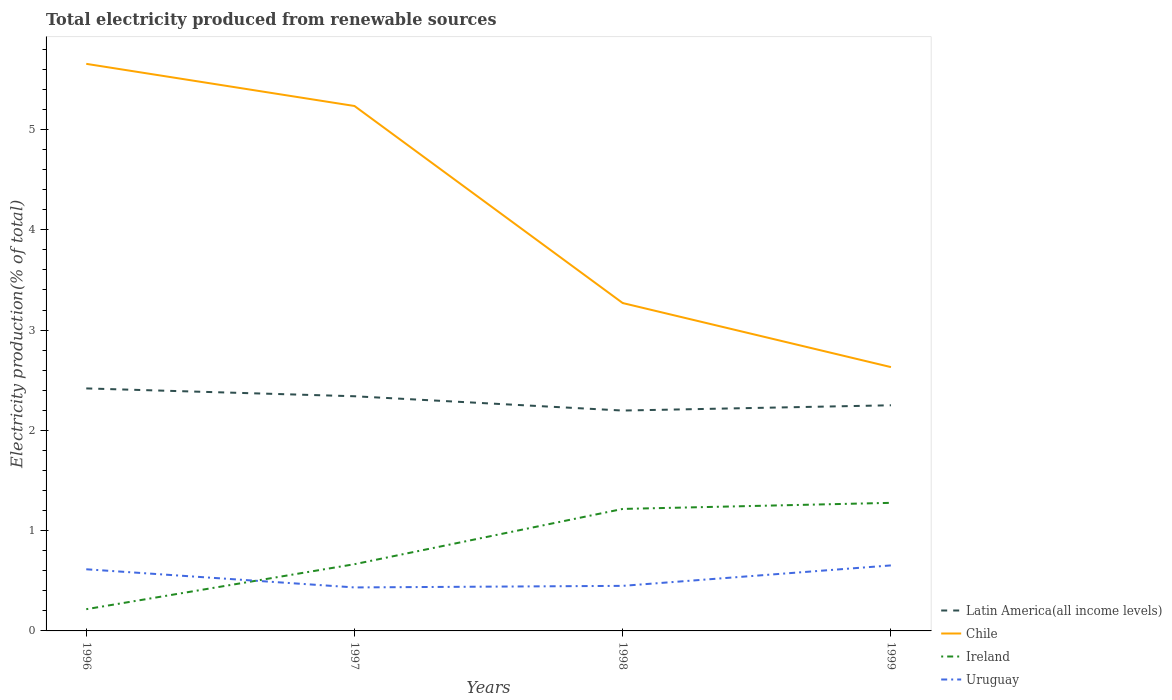Does the line corresponding to Uruguay intersect with the line corresponding to Chile?
Your response must be concise. No. Is the number of lines equal to the number of legend labels?
Your answer should be very brief. Yes. Across all years, what is the maximum total electricity produced in Uruguay?
Offer a terse response. 0.43. What is the total total electricity produced in Ireland in the graph?
Keep it short and to the point. -1.06. What is the difference between the highest and the second highest total electricity produced in Chile?
Your answer should be very brief. 3.02. What is the difference between the highest and the lowest total electricity produced in Ireland?
Give a very brief answer. 2. How many lines are there?
Offer a terse response. 4. What is the difference between two consecutive major ticks on the Y-axis?
Provide a short and direct response. 1. Where does the legend appear in the graph?
Provide a succinct answer. Bottom right. How are the legend labels stacked?
Offer a terse response. Vertical. What is the title of the graph?
Your response must be concise. Total electricity produced from renewable sources. What is the Electricity production(% of total) of Latin America(all income levels) in 1996?
Your answer should be compact. 2.42. What is the Electricity production(% of total) in Chile in 1996?
Your answer should be very brief. 5.66. What is the Electricity production(% of total) in Ireland in 1996?
Keep it short and to the point. 0.22. What is the Electricity production(% of total) of Uruguay in 1996?
Offer a terse response. 0.61. What is the Electricity production(% of total) in Latin America(all income levels) in 1997?
Give a very brief answer. 2.34. What is the Electricity production(% of total) in Chile in 1997?
Offer a terse response. 5.23. What is the Electricity production(% of total) in Ireland in 1997?
Offer a terse response. 0.67. What is the Electricity production(% of total) of Uruguay in 1997?
Provide a short and direct response. 0.43. What is the Electricity production(% of total) in Latin America(all income levels) in 1998?
Ensure brevity in your answer.  2.2. What is the Electricity production(% of total) in Chile in 1998?
Make the answer very short. 3.27. What is the Electricity production(% of total) of Ireland in 1998?
Give a very brief answer. 1.22. What is the Electricity production(% of total) in Uruguay in 1998?
Offer a very short reply. 0.45. What is the Electricity production(% of total) in Latin America(all income levels) in 1999?
Offer a very short reply. 2.25. What is the Electricity production(% of total) of Chile in 1999?
Offer a very short reply. 2.63. What is the Electricity production(% of total) of Ireland in 1999?
Give a very brief answer. 1.28. What is the Electricity production(% of total) in Uruguay in 1999?
Offer a terse response. 0.65. Across all years, what is the maximum Electricity production(% of total) of Latin America(all income levels)?
Offer a terse response. 2.42. Across all years, what is the maximum Electricity production(% of total) of Chile?
Keep it short and to the point. 5.66. Across all years, what is the maximum Electricity production(% of total) in Ireland?
Keep it short and to the point. 1.28. Across all years, what is the maximum Electricity production(% of total) of Uruguay?
Offer a terse response. 0.65. Across all years, what is the minimum Electricity production(% of total) of Latin America(all income levels)?
Offer a very short reply. 2.2. Across all years, what is the minimum Electricity production(% of total) of Chile?
Your answer should be very brief. 2.63. Across all years, what is the minimum Electricity production(% of total) of Ireland?
Your answer should be compact. 0.22. Across all years, what is the minimum Electricity production(% of total) in Uruguay?
Your answer should be compact. 0.43. What is the total Electricity production(% of total) of Latin America(all income levels) in the graph?
Provide a short and direct response. 9.21. What is the total Electricity production(% of total) in Chile in the graph?
Offer a very short reply. 16.79. What is the total Electricity production(% of total) of Ireland in the graph?
Make the answer very short. 3.38. What is the total Electricity production(% of total) of Uruguay in the graph?
Offer a terse response. 2.15. What is the difference between the Electricity production(% of total) of Latin America(all income levels) in 1996 and that in 1997?
Make the answer very short. 0.08. What is the difference between the Electricity production(% of total) in Chile in 1996 and that in 1997?
Your answer should be compact. 0.42. What is the difference between the Electricity production(% of total) in Ireland in 1996 and that in 1997?
Give a very brief answer. -0.45. What is the difference between the Electricity production(% of total) of Uruguay in 1996 and that in 1997?
Offer a terse response. 0.18. What is the difference between the Electricity production(% of total) of Latin America(all income levels) in 1996 and that in 1998?
Make the answer very short. 0.22. What is the difference between the Electricity production(% of total) of Chile in 1996 and that in 1998?
Provide a short and direct response. 2.39. What is the difference between the Electricity production(% of total) in Ireland in 1996 and that in 1998?
Your answer should be compact. -1. What is the difference between the Electricity production(% of total) in Uruguay in 1996 and that in 1998?
Your answer should be compact. 0.17. What is the difference between the Electricity production(% of total) in Latin America(all income levels) in 1996 and that in 1999?
Your answer should be very brief. 0.17. What is the difference between the Electricity production(% of total) of Chile in 1996 and that in 1999?
Keep it short and to the point. 3.02. What is the difference between the Electricity production(% of total) of Ireland in 1996 and that in 1999?
Give a very brief answer. -1.06. What is the difference between the Electricity production(% of total) in Uruguay in 1996 and that in 1999?
Your answer should be compact. -0.04. What is the difference between the Electricity production(% of total) in Latin America(all income levels) in 1997 and that in 1998?
Give a very brief answer. 0.14. What is the difference between the Electricity production(% of total) in Chile in 1997 and that in 1998?
Your response must be concise. 1.97. What is the difference between the Electricity production(% of total) in Ireland in 1997 and that in 1998?
Give a very brief answer. -0.55. What is the difference between the Electricity production(% of total) of Uruguay in 1997 and that in 1998?
Your answer should be compact. -0.02. What is the difference between the Electricity production(% of total) in Latin America(all income levels) in 1997 and that in 1999?
Give a very brief answer. 0.09. What is the difference between the Electricity production(% of total) of Chile in 1997 and that in 1999?
Give a very brief answer. 2.6. What is the difference between the Electricity production(% of total) in Ireland in 1997 and that in 1999?
Provide a short and direct response. -0.61. What is the difference between the Electricity production(% of total) in Uruguay in 1997 and that in 1999?
Ensure brevity in your answer.  -0.22. What is the difference between the Electricity production(% of total) of Latin America(all income levels) in 1998 and that in 1999?
Make the answer very short. -0.05. What is the difference between the Electricity production(% of total) of Chile in 1998 and that in 1999?
Give a very brief answer. 0.64. What is the difference between the Electricity production(% of total) of Ireland in 1998 and that in 1999?
Provide a succinct answer. -0.06. What is the difference between the Electricity production(% of total) in Uruguay in 1998 and that in 1999?
Give a very brief answer. -0.2. What is the difference between the Electricity production(% of total) of Latin America(all income levels) in 1996 and the Electricity production(% of total) of Chile in 1997?
Offer a very short reply. -2.82. What is the difference between the Electricity production(% of total) of Latin America(all income levels) in 1996 and the Electricity production(% of total) of Ireland in 1997?
Provide a succinct answer. 1.75. What is the difference between the Electricity production(% of total) in Latin America(all income levels) in 1996 and the Electricity production(% of total) in Uruguay in 1997?
Offer a very short reply. 1.98. What is the difference between the Electricity production(% of total) of Chile in 1996 and the Electricity production(% of total) of Ireland in 1997?
Provide a short and direct response. 4.99. What is the difference between the Electricity production(% of total) of Chile in 1996 and the Electricity production(% of total) of Uruguay in 1997?
Offer a very short reply. 5.22. What is the difference between the Electricity production(% of total) of Ireland in 1996 and the Electricity production(% of total) of Uruguay in 1997?
Keep it short and to the point. -0.22. What is the difference between the Electricity production(% of total) of Latin America(all income levels) in 1996 and the Electricity production(% of total) of Chile in 1998?
Provide a succinct answer. -0.85. What is the difference between the Electricity production(% of total) in Latin America(all income levels) in 1996 and the Electricity production(% of total) in Ireland in 1998?
Provide a succinct answer. 1.2. What is the difference between the Electricity production(% of total) in Latin America(all income levels) in 1996 and the Electricity production(% of total) in Uruguay in 1998?
Your answer should be compact. 1.97. What is the difference between the Electricity production(% of total) in Chile in 1996 and the Electricity production(% of total) in Ireland in 1998?
Your response must be concise. 4.44. What is the difference between the Electricity production(% of total) in Chile in 1996 and the Electricity production(% of total) in Uruguay in 1998?
Keep it short and to the point. 5.21. What is the difference between the Electricity production(% of total) in Ireland in 1996 and the Electricity production(% of total) in Uruguay in 1998?
Your response must be concise. -0.23. What is the difference between the Electricity production(% of total) in Latin America(all income levels) in 1996 and the Electricity production(% of total) in Chile in 1999?
Provide a short and direct response. -0.21. What is the difference between the Electricity production(% of total) of Latin America(all income levels) in 1996 and the Electricity production(% of total) of Ireland in 1999?
Your answer should be very brief. 1.14. What is the difference between the Electricity production(% of total) of Latin America(all income levels) in 1996 and the Electricity production(% of total) of Uruguay in 1999?
Your answer should be very brief. 1.76. What is the difference between the Electricity production(% of total) in Chile in 1996 and the Electricity production(% of total) in Ireland in 1999?
Offer a terse response. 4.38. What is the difference between the Electricity production(% of total) in Chile in 1996 and the Electricity production(% of total) in Uruguay in 1999?
Make the answer very short. 5. What is the difference between the Electricity production(% of total) in Ireland in 1996 and the Electricity production(% of total) in Uruguay in 1999?
Keep it short and to the point. -0.44. What is the difference between the Electricity production(% of total) in Latin America(all income levels) in 1997 and the Electricity production(% of total) in Chile in 1998?
Offer a terse response. -0.93. What is the difference between the Electricity production(% of total) of Latin America(all income levels) in 1997 and the Electricity production(% of total) of Ireland in 1998?
Your answer should be compact. 1.12. What is the difference between the Electricity production(% of total) in Latin America(all income levels) in 1997 and the Electricity production(% of total) in Uruguay in 1998?
Keep it short and to the point. 1.89. What is the difference between the Electricity production(% of total) in Chile in 1997 and the Electricity production(% of total) in Ireland in 1998?
Make the answer very short. 4.02. What is the difference between the Electricity production(% of total) of Chile in 1997 and the Electricity production(% of total) of Uruguay in 1998?
Keep it short and to the point. 4.79. What is the difference between the Electricity production(% of total) in Ireland in 1997 and the Electricity production(% of total) in Uruguay in 1998?
Provide a short and direct response. 0.22. What is the difference between the Electricity production(% of total) in Latin America(all income levels) in 1997 and the Electricity production(% of total) in Chile in 1999?
Ensure brevity in your answer.  -0.29. What is the difference between the Electricity production(% of total) in Latin America(all income levels) in 1997 and the Electricity production(% of total) in Ireland in 1999?
Keep it short and to the point. 1.06. What is the difference between the Electricity production(% of total) in Latin America(all income levels) in 1997 and the Electricity production(% of total) in Uruguay in 1999?
Provide a short and direct response. 1.69. What is the difference between the Electricity production(% of total) of Chile in 1997 and the Electricity production(% of total) of Ireland in 1999?
Ensure brevity in your answer.  3.96. What is the difference between the Electricity production(% of total) in Chile in 1997 and the Electricity production(% of total) in Uruguay in 1999?
Ensure brevity in your answer.  4.58. What is the difference between the Electricity production(% of total) in Ireland in 1997 and the Electricity production(% of total) in Uruguay in 1999?
Give a very brief answer. 0.01. What is the difference between the Electricity production(% of total) in Latin America(all income levels) in 1998 and the Electricity production(% of total) in Chile in 1999?
Keep it short and to the point. -0.43. What is the difference between the Electricity production(% of total) in Latin America(all income levels) in 1998 and the Electricity production(% of total) in Ireland in 1999?
Your answer should be very brief. 0.92. What is the difference between the Electricity production(% of total) of Latin America(all income levels) in 1998 and the Electricity production(% of total) of Uruguay in 1999?
Give a very brief answer. 1.54. What is the difference between the Electricity production(% of total) of Chile in 1998 and the Electricity production(% of total) of Ireland in 1999?
Your answer should be compact. 1.99. What is the difference between the Electricity production(% of total) of Chile in 1998 and the Electricity production(% of total) of Uruguay in 1999?
Provide a succinct answer. 2.62. What is the difference between the Electricity production(% of total) in Ireland in 1998 and the Electricity production(% of total) in Uruguay in 1999?
Offer a very short reply. 0.56. What is the average Electricity production(% of total) of Latin America(all income levels) per year?
Make the answer very short. 2.3. What is the average Electricity production(% of total) of Chile per year?
Keep it short and to the point. 4.2. What is the average Electricity production(% of total) of Ireland per year?
Your answer should be very brief. 0.84. What is the average Electricity production(% of total) of Uruguay per year?
Make the answer very short. 0.54. In the year 1996, what is the difference between the Electricity production(% of total) of Latin America(all income levels) and Electricity production(% of total) of Chile?
Offer a terse response. -3.24. In the year 1996, what is the difference between the Electricity production(% of total) in Latin America(all income levels) and Electricity production(% of total) in Ireland?
Give a very brief answer. 2.2. In the year 1996, what is the difference between the Electricity production(% of total) of Latin America(all income levels) and Electricity production(% of total) of Uruguay?
Your answer should be very brief. 1.8. In the year 1996, what is the difference between the Electricity production(% of total) of Chile and Electricity production(% of total) of Ireland?
Keep it short and to the point. 5.44. In the year 1996, what is the difference between the Electricity production(% of total) in Chile and Electricity production(% of total) in Uruguay?
Give a very brief answer. 5.04. In the year 1996, what is the difference between the Electricity production(% of total) of Ireland and Electricity production(% of total) of Uruguay?
Your answer should be very brief. -0.4. In the year 1997, what is the difference between the Electricity production(% of total) in Latin America(all income levels) and Electricity production(% of total) in Chile?
Your answer should be compact. -2.89. In the year 1997, what is the difference between the Electricity production(% of total) in Latin America(all income levels) and Electricity production(% of total) in Ireland?
Your answer should be compact. 1.67. In the year 1997, what is the difference between the Electricity production(% of total) of Latin America(all income levels) and Electricity production(% of total) of Uruguay?
Keep it short and to the point. 1.91. In the year 1997, what is the difference between the Electricity production(% of total) of Chile and Electricity production(% of total) of Ireland?
Ensure brevity in your answer.  4.57. In the year 1997, what is the difference between the Electricity production(% of total) of Chile and Electricity production(% of total) of Uruguay?
Your answer should be compact. 4.8. In the year 1997, what is the difference between the Electricity production(% of total) of Ireland and Electricity production(% of total) of Uruguay?
Provide a succinct answer. 0.23. In the year 1998, what is the difference between the Electricity production(% of total) of Latin America(all income levels) and Electricity production(% of total) of Chile?
Your response must be concise. -1.07. In the year 1998, what is the difference between the Electricity production(% of total) of Latin America(all income levels) and Electricity production(% of total) of Ireland?
Provide a short and direct response. 0.98. In the year 1998, what is the difference between the Electricity production(% of total) of Latin America(all income levels) and Electricity production(% of total) of Uruguay?
Your answer should be compact. 1.75. In the year 1998, what is the difference between the Electricity production(% of total) in Chile and Electricity production(% of total) in Ireland?
Offer a very short reply. 2.05. In the year 1998, what is the difference between the Electricity production(% of total) of Chile and Electricity production(% of total) of Uruguay?
Ensure brevity in your answer.  2.82. In the year 1998, what is the difference between the Electricity production(% of total) in Ireland and Electricity production(% of total) in Uruguay?
Offer a very short reply. 0.77. In the year 1999, what is the difference between the Electricity production(% of total) in Latin America(all income levels) and Electricity production(% of total) in Chile?
Provide a short and direct response. -0.38. In the year 1999, what is the difference between the Electricity production(% of total) in Latin America(all income levels) and Electricity production(% of total) in Ireland?
Your response must be concise. 0.97. In the year 1999, what is the difference between the Electricity production(% of total) in Latin America(all income levels) and Electricity production(% of total) in Uruguay?
Ensure brevity in your answer.  1.6. In the year 1999, what is the difference between the Electricity production(% of total) of Chile and Electricity production(% of total) of Ireland?
Your answer should be compact. 1.35. In the year 1999, what is the difference between the Electricity production(% of total) in Chile and Electricity production(% of total) in Uruguay?
Give a very brief answer. 1.98. In the year 1999, what is the difference between the Electricity production(% of total) in Ireland and Electricity production(% of total) in Uruguay?
Your response must be concise. 0.62. What is the ratio of the Electricity production(% of total) in Latin America(all income levels) in 1996 to that in 1997?
Ensure brevity in your answer.  1.03. What is the ratio of the Electricity production(% of total) of Chile in 1996 to that in 1997?
Make the answer very short. 1.08. What is the ratio of the Electricity production(% of total) of Ireland in 1996 to that in 1997?
Offer a terse response. 0.33. What is the ratio of the Electricity production(% of total) in Uruguay in 1996 to that in 1997?
Make the answer very short. 1.42. What is the ratio of the Electricity production(% of total) in Latin America(all income levels) in 1996 to that in 1998?
Offer a terse response. 1.1. What is the ratio of the Electricity production(% of total) of Chile in 1996 to that in 1998?
Offer a very short reply. 1.73. What is the ratio of the Electricity production(% of total) of Ireland in 1996 to that in 1998?
Make the answer very short. 0.18. What is the ratio of the Electricity production(% of total) of Uruguay in 1996 to that in 1998?
Ensure brevity in your answer.  1.37. What is the ratio of the Electricity production(% of total) of Latin America(all income levels) in 1996 to that in 1999?
Provide a short and direct response. 1.07. What is the ratio of the Electricity production(% of total) of Chile in 1996 to that in 1999?
Your response must be concise. 2.15. What is the ratio of the Electricity production(% of total) in Ireland in 1996 to that in 1999?
Ensure brevity in your answer.  0.17. What is the ratio of the Electricity production(% of total) of Uruguay in 1996 to that in 1999?
Give a very brief answer. 0.94. What is the ratio of the Electricity production(% of total) of Latin America(all income levels) in 1997 to that in 1998?
Keep it short and to the point. 1.06. What is the ratio of the Electricity production(% of total) of Chile in 1997 to that in 1998?
Keep it short and to the point. 1.6. What is the ratio of the Electricity production(% of total) in Ireland in 1997 to that in 1998?
Offer a terse response. 0.55. What is the ratio of the Electricity production(% of total) in Latin America(all income levels) in 1997 to that in 1999?
Make the answer very short. 1.04. What is the ratio of the Electricity production(% of total) of Chile in 1997 to that in 1999?
Ensure brevity in your answer.  1.99. What is the ratio of the Electricity production(% of total) in Ireland in 1997 to that in 1999?
Offer a very short reply. 0.52. What is the ratio of the Electricity production(% of total) of Uruguay in 1997 to that in 1999?
Offer a very short reply. 0.66. What is the ratio of the Electricity production(% of total) of Latin America(all income levels) in 1998 to that in 1999?
Offer a terse response. 0.98. What is the ratio of the Electricity production(% of total) in Chile in 1998 to that in 1999?
Make the answer very short. 1.24. What is the ratio of the Electricity production(% of total) of Ireland in 1998 to that in 1999?
Ensure brevity in your answer.  0.95. What is the ratio of the Electricity production(% of total) of Uruguay in 1998 to that in 1999?
Provide a succinct answer. 0.69. What is the difference between the highest and the second highest Electricity production(% of total) of Latin America(all income levels)?
Ensure brevity in your answer.  0.08. What is the difference between the highest and the second highest Electricity production(% of total) in Chile?
Your answer should be very brief. 0.42. What is the difference between the highest and the second highest Electricity production(% of total) in Ireland?
Offer a very short reply. 0.06. What is the difference between the highest and the second highest Electricity production(% of total) in Uruguay?
Give a very brief answer. 0.04. What is the difference between the highest and the lowest Electricity production(% of total) of Latin America(all income levels)?
Ensure brevity in your answer.  0.22. What is the difference between the highest and the lowest Electricity production(% of total) in Chile?
Your answer should be compact. 3.02. What is the difference between the highest and the lowest Electricity production(% of total) in Ireland?
Your answer should be compact. 1.06. What is the difference between the highest and the lowest Electricity production(% of total) of Uruguay?
Make the answer very short. 0.22. 